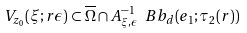Convert formula to latex. <formula><loc_0><loc_0><loc_500><loc_500>V _ { z _ { 0 } } ( \xi ; r \epsilon ) \subset \overline { \Omega } \cap A ^ { - 1 } _ { \xi , \epsilon } \ B b _ { d } ( e _ { 1 } ; \tau _ { 2 } ( r ) )</formula> 